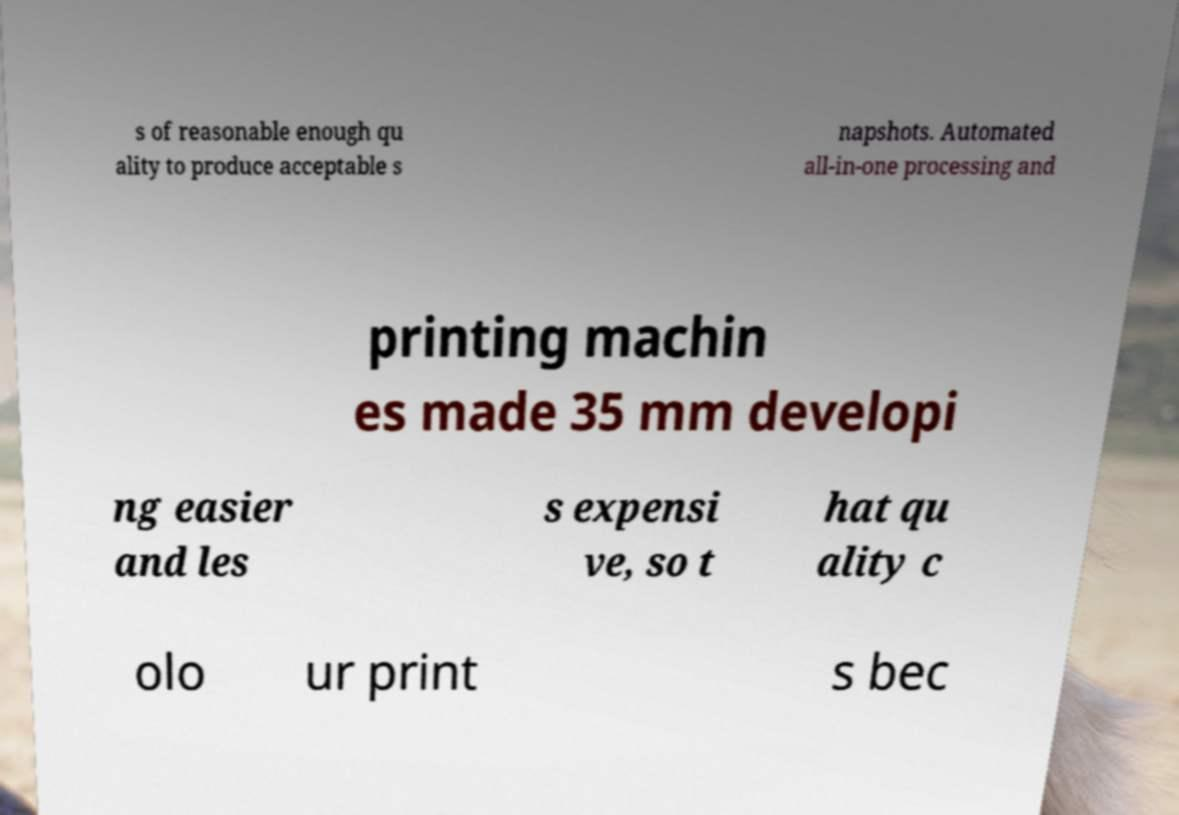Can you read and provide the text displayed in the image?This photo seems to have some interesting text. Can you extract and type it out for me? s of reasonable enough qu ality to produce acceptable s napshots. Automated all-in-one processing and printing machin es made 35 mm developi ng easier and les s expensi ve, so t hat qu ality c olo ur print s bec 